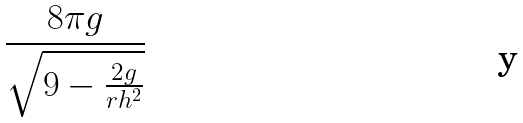Convert formula to latex. <formula><loc_0><loc_0><loc_500><loc_500>\frac { 8 \pi g } { \sqrt { 9 - \frac { 2 g } { r h ^ { 2 } } } }</formula> 